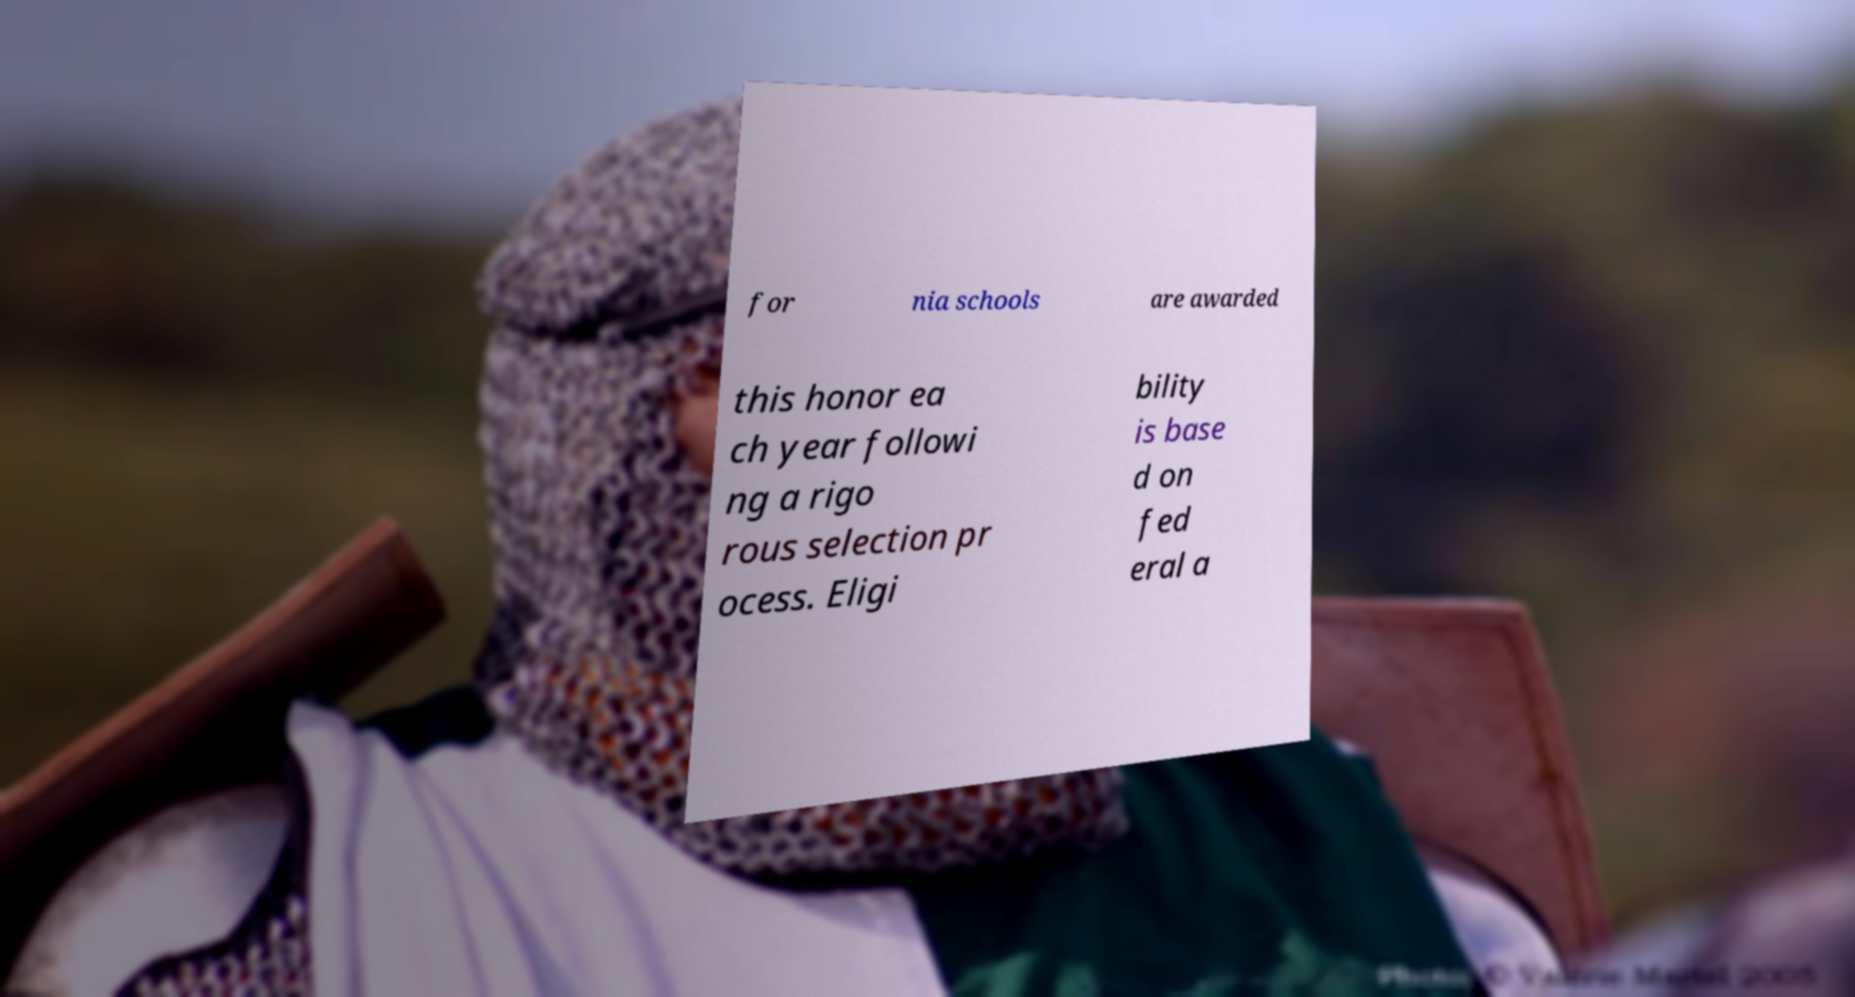There's text embedded in this image that I need extracted. Can you transcribe it verbatim? for nia schools are awarded this honor ea ch year followi ng a rigo rous selection pr ocess. Eligi bility is base d on fed eral a 